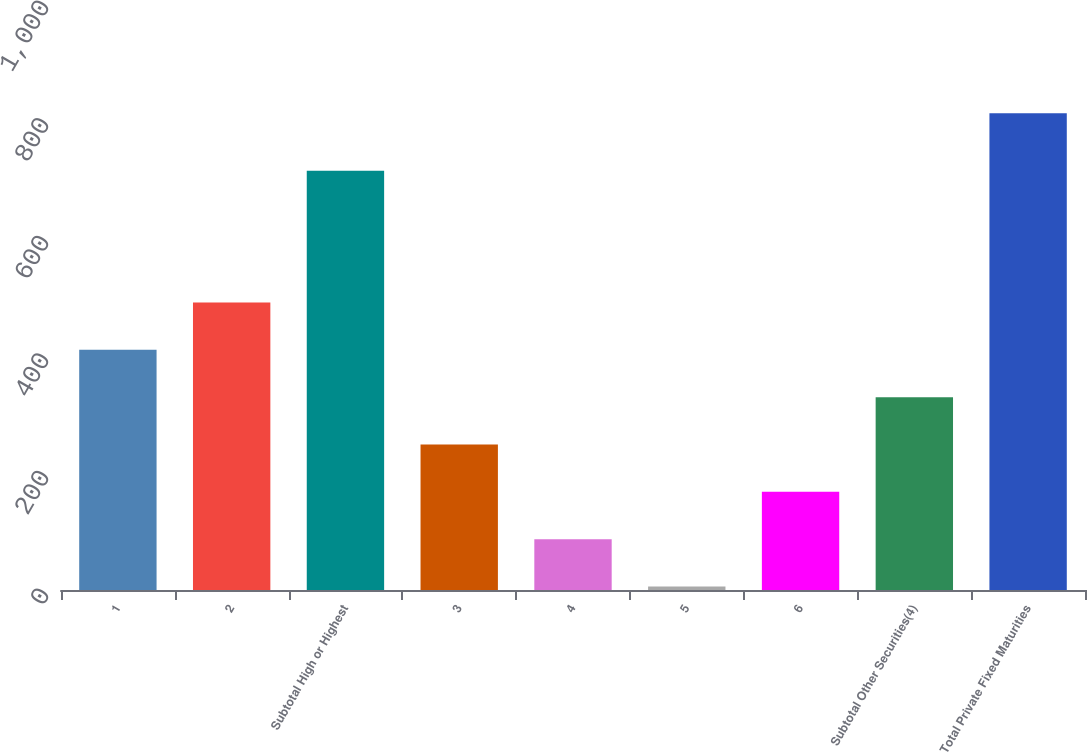Convert chart to OTSL. <chart><loc_0><loc_0><loc_500><loc_500><bar_chart><fcel>1<fcel>2<fcel>Subtotal High or Highest<fcel>3<fcel>4<fcel>5<fcel>6<fcel>Subtotal Other Securities(4)<fcel>Total Private Fixed Maturities<nl><fcel>408.5<fcel>489<fcel>713<fcel>247.5<fcel>86.5<fcel>6<fcel>167<fcel>328<fcel>811<nl></chart> 